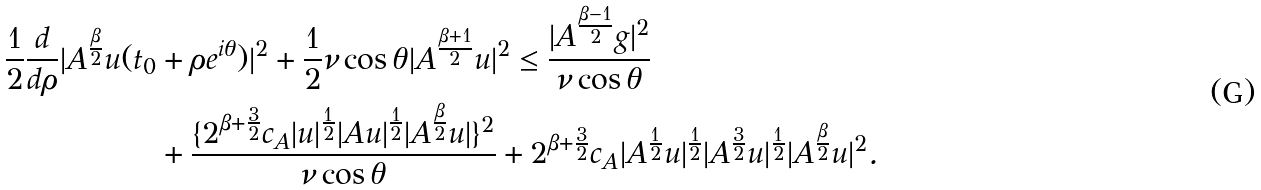Convert formula to latex. <formula><loc_0><loc_0><loc_500><loc_500>\frac { 1 } { 2 } \frac { d } { d \rho } | A ^ { \frac { \beta } { 2 } } u ( t _ { 0 } & + \rho e ^ { i \theta } ) | ^ { 2 } + \frac { 1 } { 2 } \nu \cos \theta | A ^ { \frac { \beta + 1 } { 2 } } u | ^ { 2 } \leq \frac { | A ^ { \frac { \beta - 1 } { 2 } } g | ^ { 2 } } { \nu \cos \theta } \\ & + \frac { \{ { 2 ^ { \beta + \frac { 3 } { 2 } } c _ { A } } | u | ^ { \frac { 1 } { 2 } } | A u | ^ { \frac { 1 } { 2 } } | A ^ { \frac { \beta } { 2 } } { u } | \} ^ { 2 } } { \nu \cos \theta } + { 2 ^ { \beta + \frac { 3 } { 2 } } c _ { A } } | A ^ { \frac { 1 } { 2 } } { u } | ^ { \frac { 1 } { 2 } } | A ^ { \frac { 3 } { 2 } } { u } | ^ { \frac { 1 } { 2 } } | A ^ { \frac { \beta } { 2 } } { u } | ^ { 2 } .</formula> 